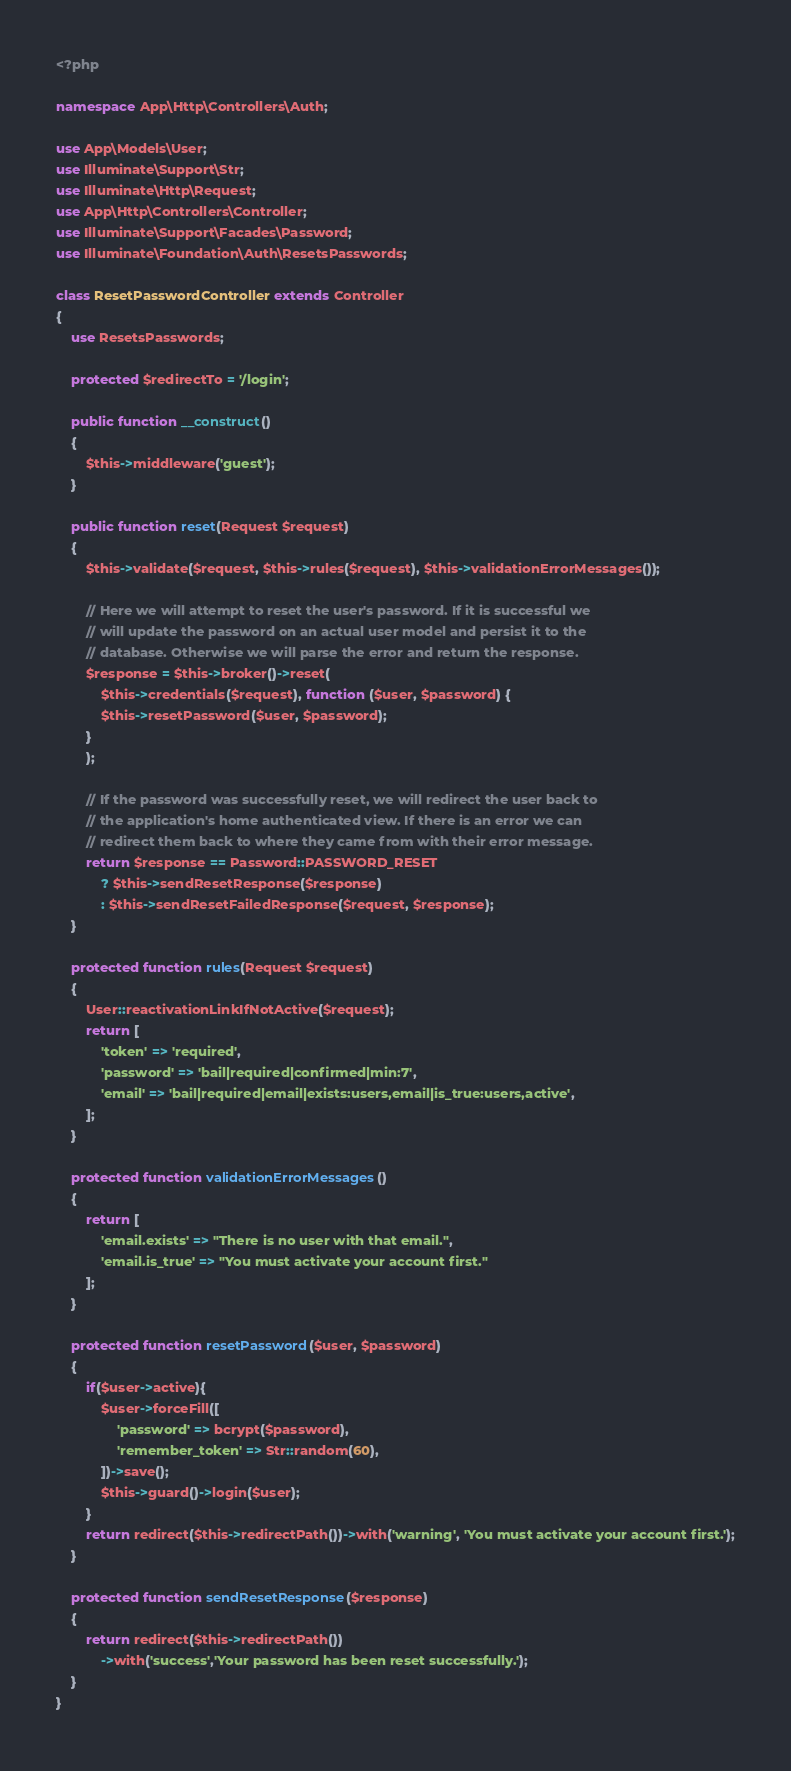Convert code to text. <code><loc_0><loc_0><loc_500><loc_500><_PHP_><?php

namespace App\Http\Controllers\Auth;

use App\Models\User;
use Illuminate\Support\Str;
use Illuminate\Http\Request;
use App\Http\Controllers\Controller;
use Illuminate\Support\Facades\Password;
use Illuminate\Foundation\Auth\ResetsPasswords;

class ResetPasswordController extends Controller
{
    use ResetsPasswords;

    protected $redirectTo = '/login';

    public function __construct()
    {
        $this->middleware('guest');
    }

    public function reset(Request $request)
    {
        $this->validate($request, $this->rules($request), $this->validationErrorMessages());

        // Here we will attempt to reset the user's password. If it is successful we
        // will update the password on an actual user model and persist it to the
        // database. Otherwise we will parse the error and return the response.
        $response = $this->broker()->reset(
            $this->credentials($request), function ($user, $password) {
            $this->resetPassword($user, $password);
        }
        );

        // If the password was successfully reset, we will redirect the user back to
        // the application's home authenticated view. If there is an error we can
        // redirect them back to where they came from with their error message.
        return $response == Password::PASSWORD_RESET
            ? $this->sendResetResponse($response)
            : $this->sendResetFailedResponse($request, $response);
    }

    protected function rules(Request $request)
    {
        User::reactivationLinkIfNotActive($request);
        return [
            'token' => 'required',
            'password' => 'bail|required|confirmed|min:7',
            'email' => 'bail|required|email|exists:users,email|is_true:users,active',
        ];
    }

    protected function validationErrorMessages()
    {
        return [
            'email.exists' => "There is no user with that email.",
            'email.is_true' => "You must activate your account first."
        ];
    }

    protected function resetPassword($user, $password)
    {
        if($user->active){
            $user->forceFill([
                'password' => bcrypt($password),
                'remember_token' => Str::random(60),
            ])->save();
            $this->guard()->login($user);
        }
        return redirect($this->redirectPath())->with('warning', 'You must activate your account first.');
    }

    protected function sendResetResponse($response)
    {
        return redirect($this->redirectPath())
            ->with('success','Your password has been reset successfully.');
    }
}
</code> 